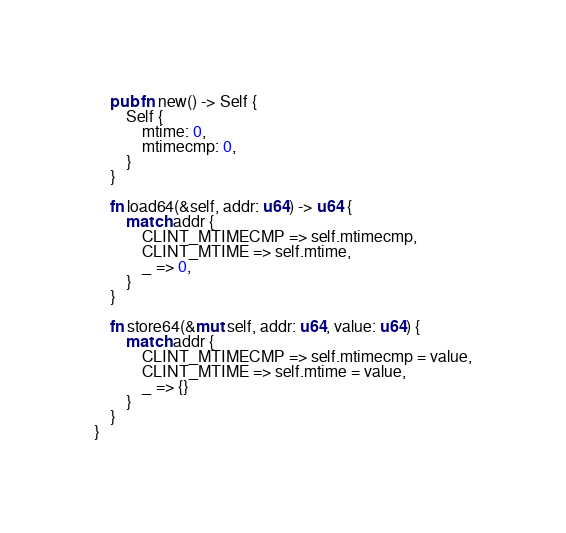<code> <loc_0><loc_0><loc_500><loc_500><_Rust_>    pub fn new() -> Self {
        Self {
            mtime: 0,
            mtimecmp: 0,
        }
    }

    fn load64(&self, addr: u64) -> u64 {
        match addr {
            CLINT_MTIMECMP => self.mtimecmp,
            CLINT_MTIME => self.mtime,
            _ => 0,
        }
    }

    fn store64(&mut self, addr: u64, value: u64) {
        match addr {
            CLINT_MTIMECMP => self.mtimecmp = value,
            CLINT_MTIME => self.mtime = value,
            _ => {}
        }
    }
}
</code> 